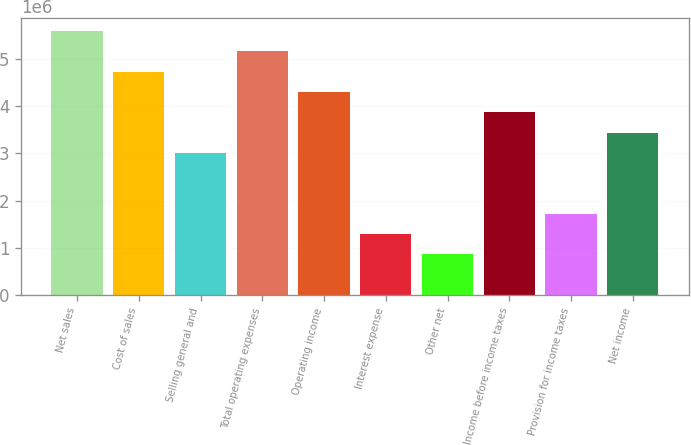<chart> <loc_0><loc_0><loc_500><loc_500><bar_chart><fcel>Net sales<fcel>Cost of sales<fcel>Selling general and<fcel>Total operating expenses<fcel>Operating income<fcel>Interest expense<fcel>Other net<fcel>Income before income taxes<fcel>Provision for income taxes<fcel>Net income<nl><fcel>5.59022e+06<fcel>4.73019e+06<fcel>3.01012e+06<fcel>5.1602e+06<fcel>4.30017e+06<fcel>1.29005e+06<fcel>860036<fcel>3.87015e+06<fcel>1.72007e+06<fcel>3.44014e+06<nl></chart> 